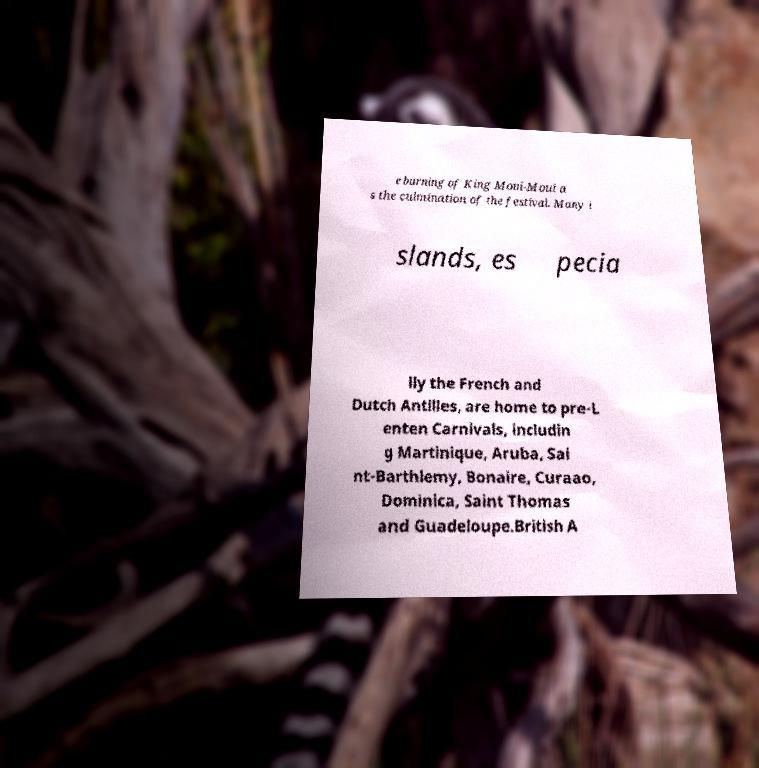Could you assist in decoding the text presented in this image and type it out clearly? e burning of King Moui-Moui a s the culmination of the festival. Many i slands, es pecia lly the French and Dutch Antilles, are home to pre-L enten Carnivals, includin g Martinique, Aruba, Sai nt-Barthlemy, Bonaire, Curaao, Dominica, Saint Thomas and Guadeloupe.British A 